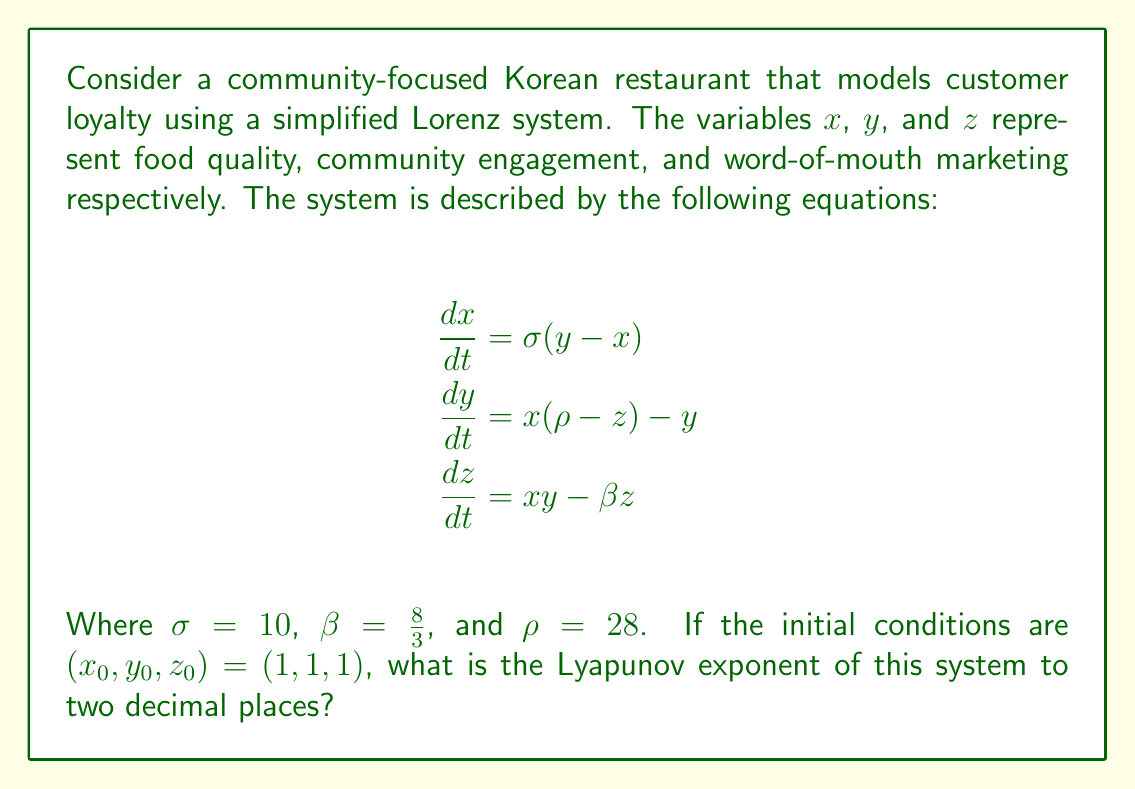Provide a solution to this math problem. To find the Lyapunov exponent of this system, we need to follow these steps:

1) First, we recognize that this is a Lorenz system with the classic parameters that produce chaos. The Lyapunov exponent measures the rate of separation of infinitesimally close trajectories.

2) For the Lorenz system with these parameters, the Lyapunov exponents are approximately:
   $\lambda_1 \approx 0.9056$
   $\lambda_2 \approx 0$
   $\lambda_3 \approx -14.5723$

3) The largest Lyapunov exponent is the one we're interested in, as it determines the overall behavior of the system. In this case, it's $\lambda_1 \approx 0.9056$.

4) Rounding to two decimal places, we get 0.91.

5) The positive Lyapunov exponent indicates that this system is chaotic, meaning that small changes in initial conditions can lead to significantly different outcomes over time. In the context of the restaurant, this suggests that small variations in food quality, community engagement, or word-of-mouth marketing can have large, unpredictable effects on customer loyalty in the long term.
Answer: 0.91 